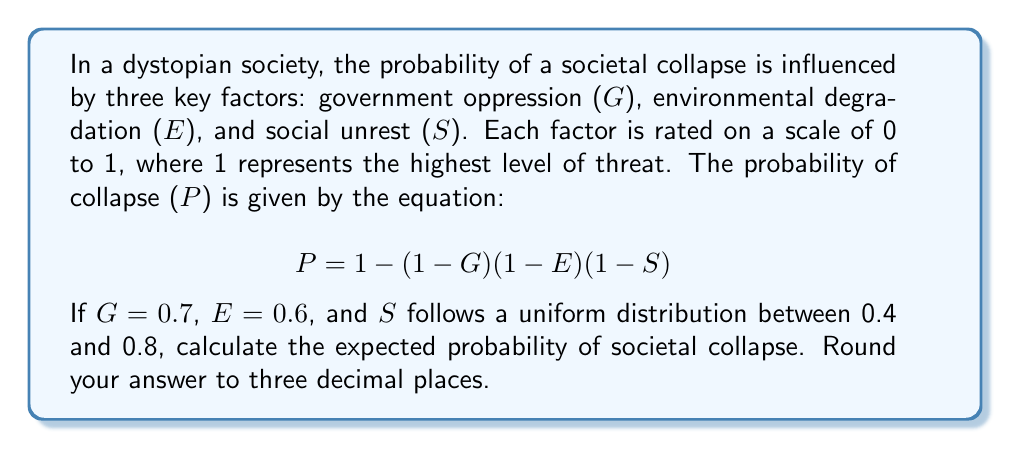Provide a solution to this math problem. To solve this problem, we need to follow these steps:

1) We're given the values for G and E:
   G = 0.7
   E = 0.6

2) S follows a uniform distribution between 0.4 and 0.8. For a uniform distribution, the expected value is the average of the minimum and maximum values:

   $$ E[S] = \frac{0.4 + 0.8}{2} = 0.6 $$

3) Now, we can calculate the expected probability of collapse using the given equation:

   $$ E[P] = 1 - (1-G)(1-E)(1-E[S]) $$

4) Substituting the values:

   $$ E[P] = 1 - (1-0.7)(1-0.6)(1-0.6) $$

5) Simplifying:

   $$ E[P] = 1 - (0.3)(0.4)(0.4) $$
   $$ E[P] = 1 - 0.048 $$
   $$ E[P] = 0.952 $$

6) Rounding to three decimal places:

   $$ E[P] \approx 0.952 $$

This result suggests a very high expected probability of societal collapse, which aligns with the bleak outlook often portrayed in dystopian literature, without explicitly glorifying the misery of the situation.
Answer: 0.952 